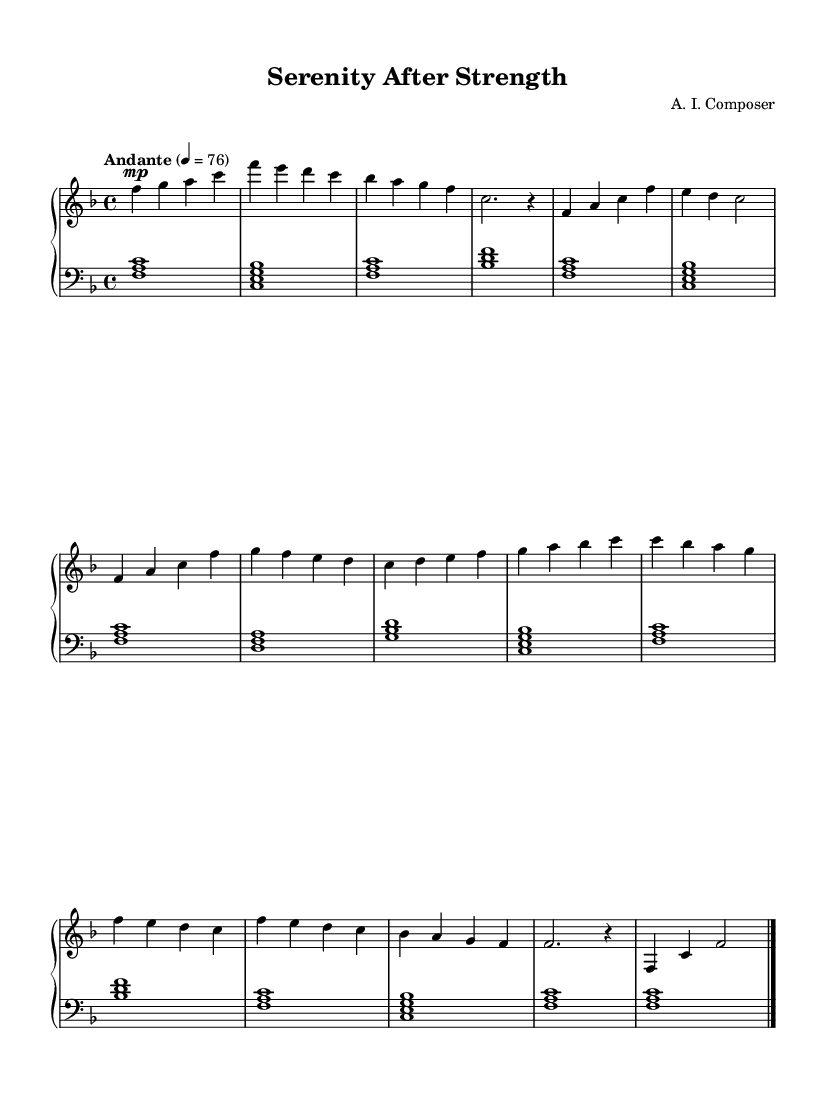What is the key signature of this music? The key signature shown in the music indicates F major, which has one flat (B flat). This is determined by looking at the symbols at the beginning of the staff associated with the notes.
Answer: F major What is the time signature of this music? The time signature is 4/4, as indicated at the beginning of the score. This means there are four beats in each measure and the quarter note gets one beat.
Answer: 4/4 What is the tempo marking for this piece? The tempo marking indicates "Andante" with a metronome marking of 76, which suggests a moderately slow pace. The word "Andante" typically means at a walking speed, and the numeric marking provides a specific beats per minute reference.
Answer: Andante, 76 How many themes are introduced in the music? The music introduces two distinct themes labeled as Theme A and Theme B, which can be identified by their unique melodic lines present throughout the piece.
Answer: Two What chord is used in the first measure of the lower staff? The first measure of the lower staff contains the chord F major, which consists of the notes F, A, and C played together. This can be identified by the bass clef notes written in the measure.
Answer: F major What is the dynamic marking for the introduction section? The introduction section has a dynamic marking of "mp," which means mezzo-piano, indicating a moderately soft volume. This marking is located before the notes in the upper staff and sets the desired intensity for that section.
Answer: mp 